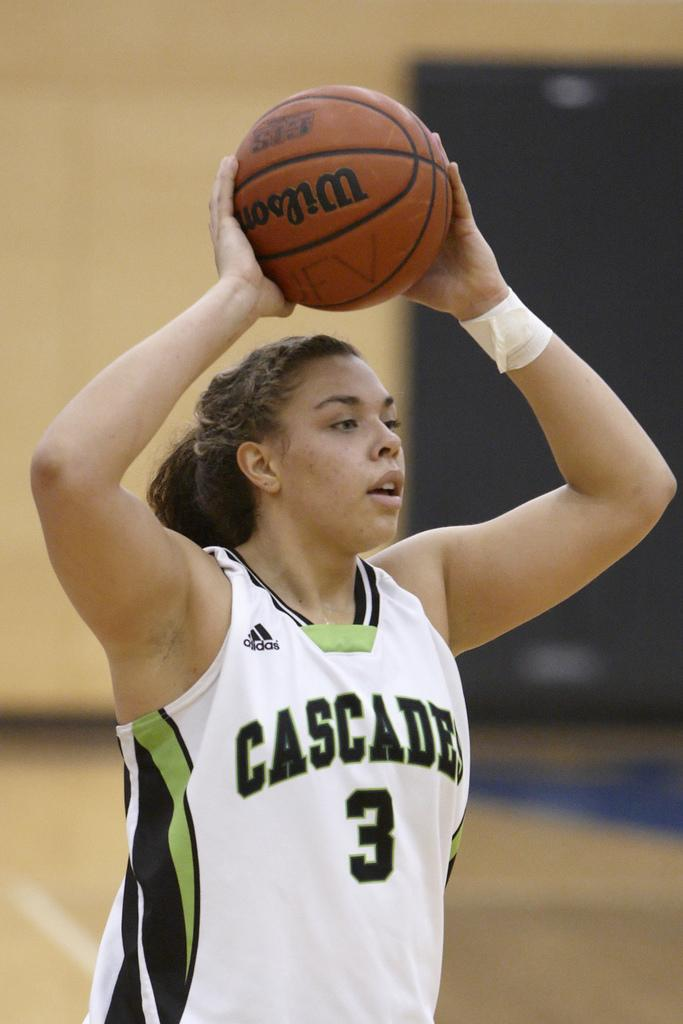<image>
Describe the image concisely. A female basketball player is about to throw the ball and her uniform says Cascades 3. 